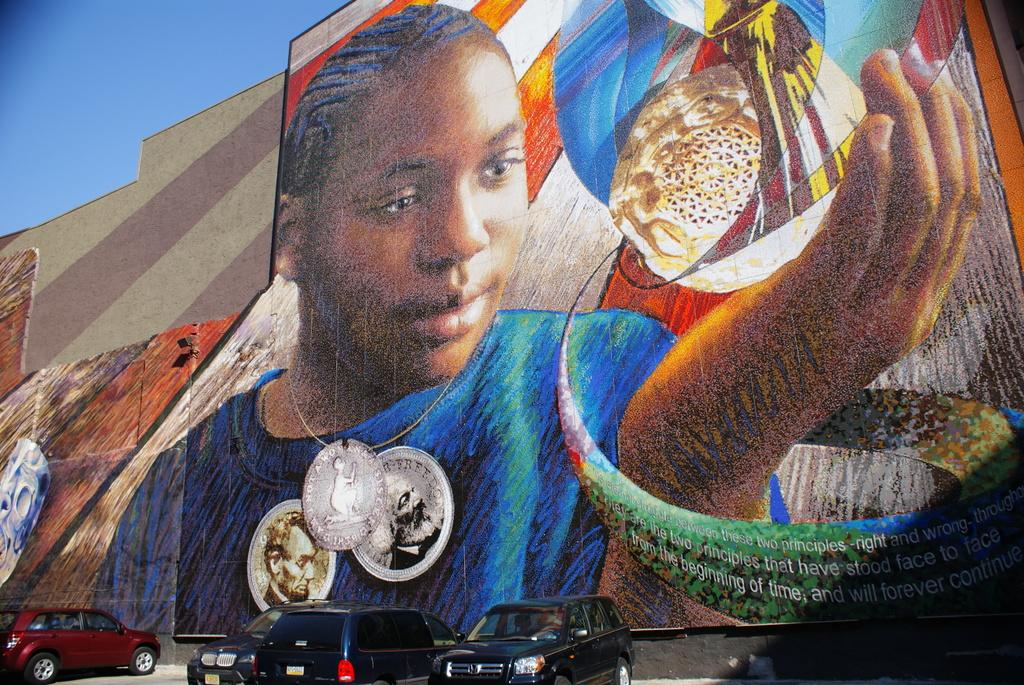What type of vehicles are at the bottom of the image? There are cars at the bottom of the image. What is located in the center of the image? There is a wall in the center of the image. What is depicted on the wall? There is a painting on the wall. What is visible at the top of the image? The sky is visible at the top of the image. How many fingers can be seen interacting with the painting in the image? There is no reference to fingers or any interaction with the painting in the image. 